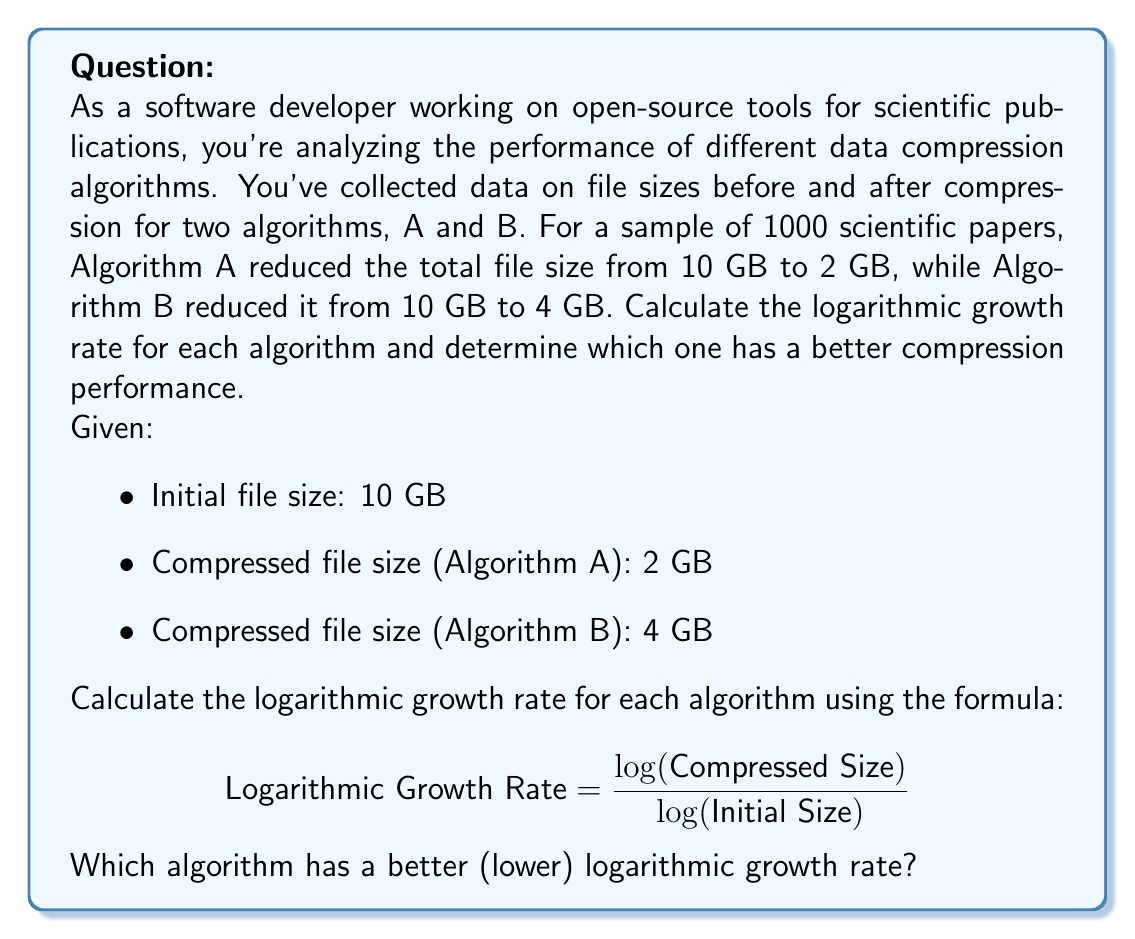Show me your answer to this math problem. To solve this problem, we'll follow these steps:

1. Calculate the logarithmic growth rate for Algorithm A
2. Calculate the logarithmic growth rate for Algorithm B
3. Compare the results

Step 1: Logarithmic growth rate for Algorithm A

$$ \text{Rate}_A = \frac{\log(2)}{\log(10)} $$

$$ \text{Rate}_A = \frac{0.30103}{1} = 0.30103 $$

Step 2: Logarithmic growth rate for Algorithm B

$$ \text{Rate}_B = \frac{\log(4)}{\log(10)} $$

$$ \text{Rate}_B = \frac{0.60206}{1} = 0.60206 $$

Step 3: Compare the results

The logarithmic growth rate for Algorithm A (0.30103) is lower than that of Algorithm B (0.60206). 

In the context of data compression, a lower logarithmic growth rate indicates better compression performance. This is because the logarithmic growth rate represents how quickly the compressed file size grows in relation to the original file size. A lower rate means the compressed file size grows more slowly, implying better compression.

Therefore, Algorithm A has a better (lower) logarithmic growth rate and demonstrates superior compression performance compared to Algorithm B.
Answer: Algorithm A has a better (lower) logarithmic growth rate of 0.30103, compared to Algorithm B's rate of 0.60206. Thus, Algorithm A demonstrates superior compression performance. 